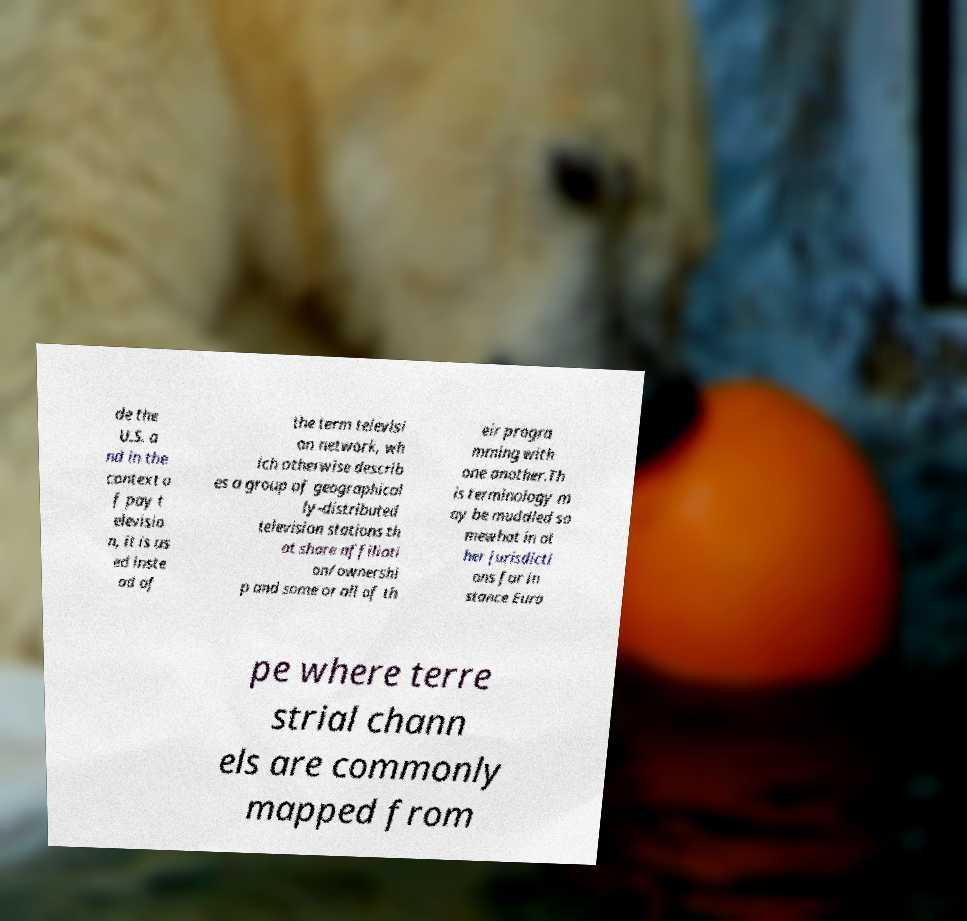Can you accurately transcribe the text from the provided image for me? de the U.S. a nd in the context o f pay t elevisio n, it is us ed inste ad of the term televisi on network, wh ich otherwise describ es a group of geographical ly-distributed television stations th at share affiliati on/ownershi p and some or all of th eir progra mming with one another.Th is terminology m ay be muddled so mewhat in ot her jurisdicti ons for in stance Euro pe where terre strial chann els are commonly mapped from 